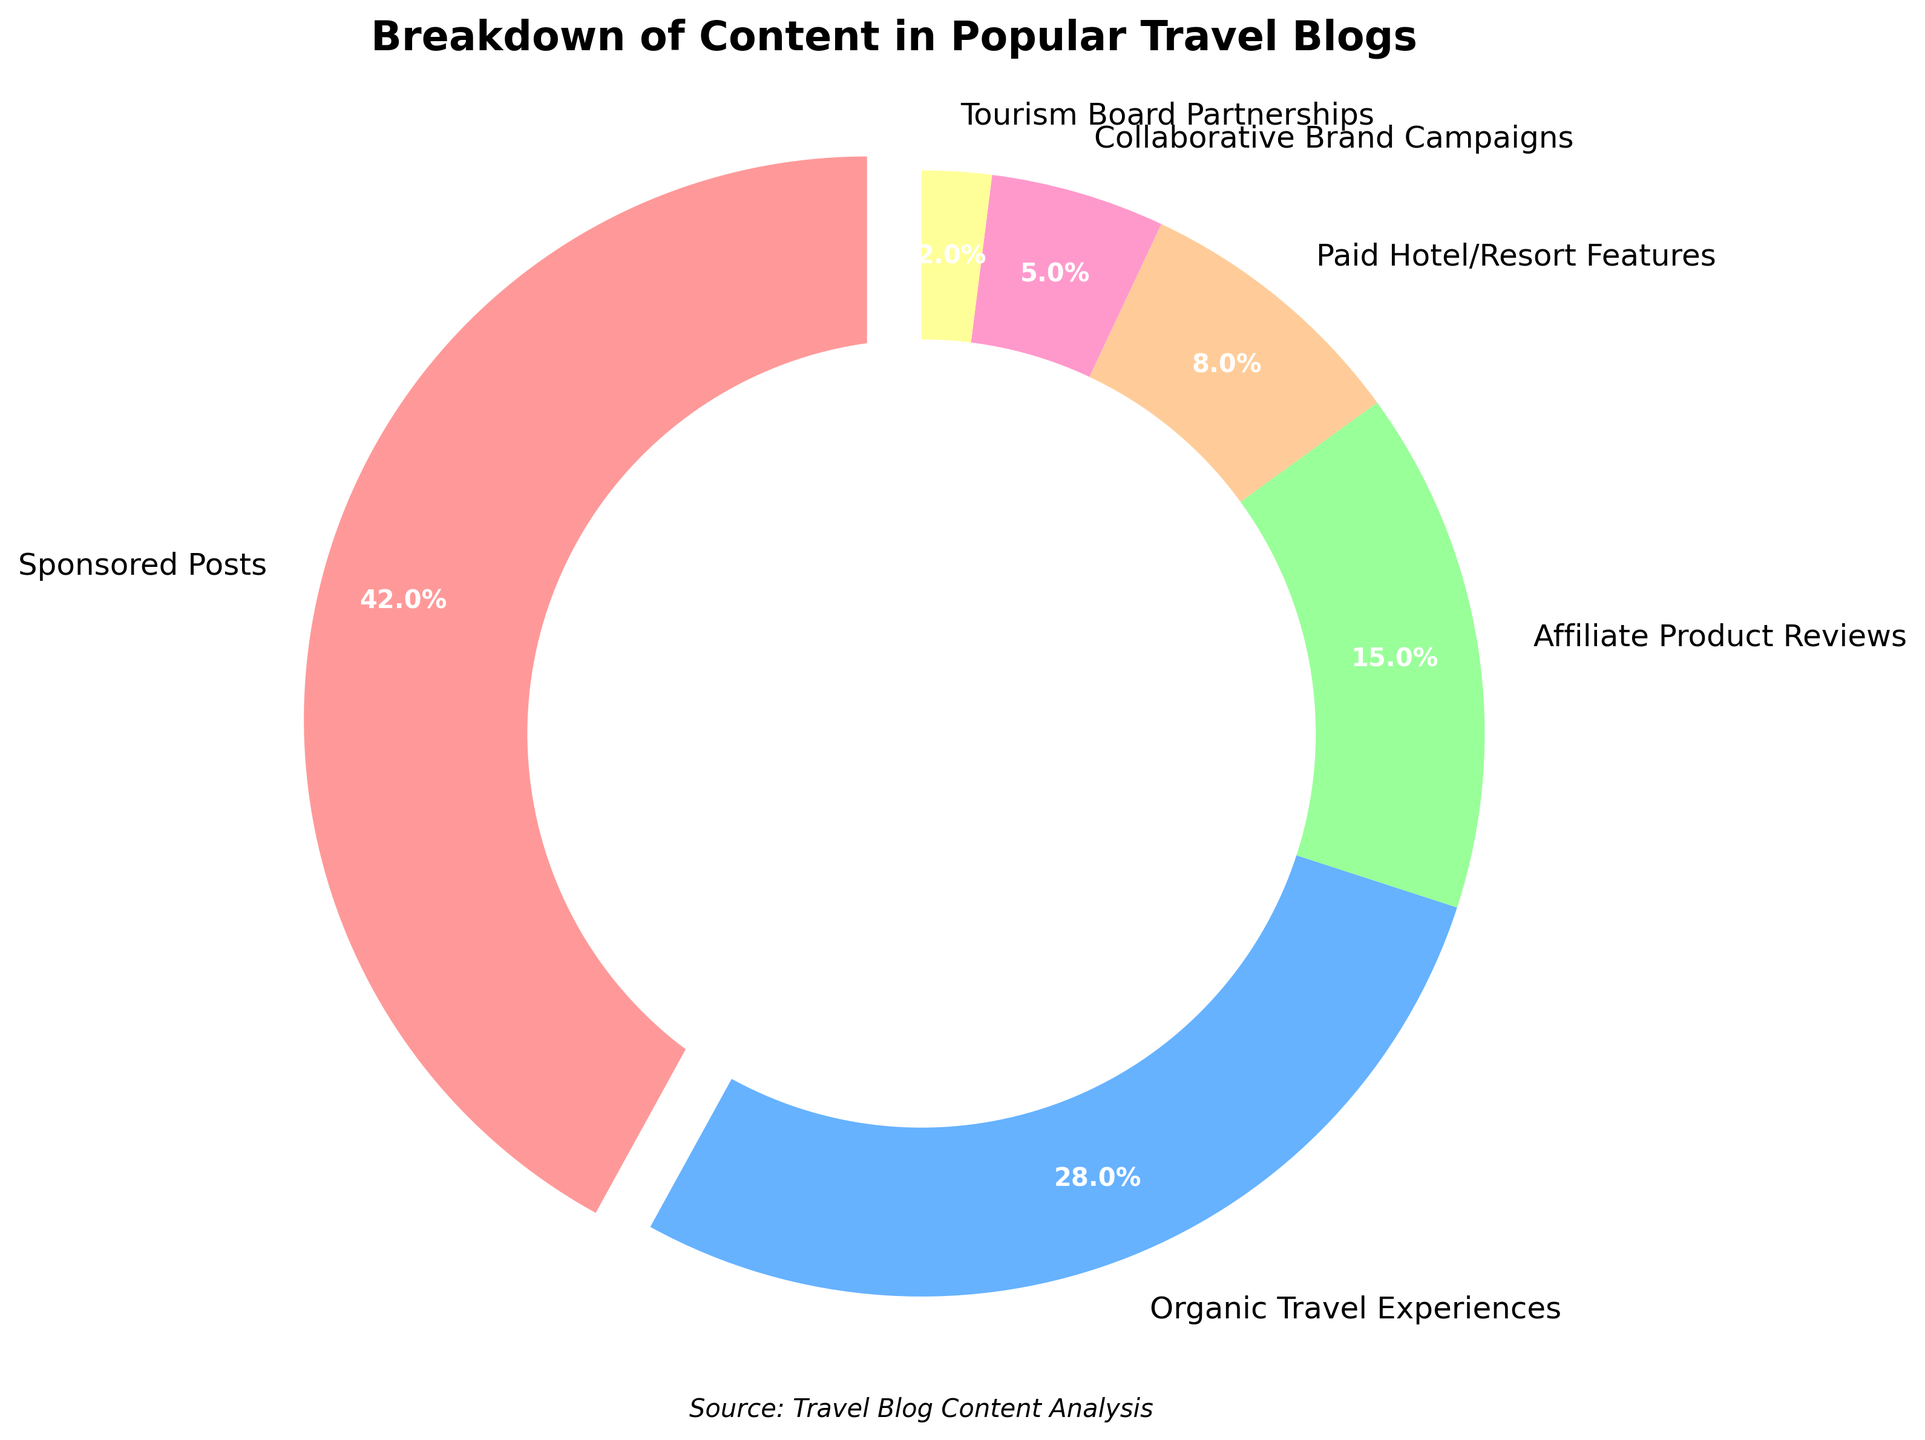What percentage of content in popular travel blogs is sponsored? According to the pie chart, "Sponsored Posts" account for a specific percentage of the total content. Inspect the label for "Sponsored Posts" to find this value.
Answer: 42% Which type of content has the smallest percentage in the pie chart? The pie chart shows several content types with their corresponding percentages. The label with the smallest value represents the type of content with the smallest percentage.
Answer: Tourism Board Partnerships What is the combined percentage of Affiliate Product Reviews and Paid Hotel/Resort Features? Find the individual percentages for "Affiliate Product Reviews" and "Paid Hotel/Resort Features." Add these two values together to get the combined percentage.
Answer: Affiliate Product Reviews (15%) + Paid Hotel/Resort Features (8%) = 23% Which has a higher percentage: Organic Travel Experiences or Collaborative Brand Campaigns? Compare the percentages given for "Organic Travel Experiences" and "Collaborative Brand Campaigns." Determine which one is higher.
Answer: Organic Travel Experiences How much larger is the percentage of Sponsored Posts compared to Organic Travel Experiences? Subtract the percentage of Organic Travel Experiences from the percentage of Sponsored Posts to find the difference.
Answer: 42% - 28% = 14% Which content type is represented by the red color? Identify the slice in the pie chart that is colored red. Check the corresponding label to determine the content type.
Answer: Sponsored Posts What percentage of content is not sponsored, if sponsored content includes Sponsored Posts, Paid Hotel/Resort Features, and Tourism Board Partnerships? Add the percentages of "Sponsored Posts," "Paid Hotel/Resort Features," and "Tourism Board Partnerships" to get the total sponsored content. Subtract this from 100% to find the remaining unsponsored content.
Answer: Sponsored Posts (42%) + Paid Hotel/Resort Features (8%) + Tourism Board Partnerships (2%) = 52%; 100% - 52% = 48% Is the percentage of Collaborative Brand Campaigns greater than or equal to Tourism Board Partnerships combined with Organic Travel Experiences? Add the percentages of "Tourism Board Partnerships" and "Organic Travel Experiences." Compare this sum with the percentage of "Collaborative Brand Campaigns."
Answer: Tourism Board Partnerships (2%) + Organic Travel Experiences (28%) = 30%; Collaborative Brand Campaigns = 5%; 5% is not greater than or equal to 30% What is the median percentage value among all the content types? Arrange the percentages in ascending order: 2%, 5%, 8%, 15%, 28%, 42%. With an even number of values, the median is the average of the two middle figures in this list.
Answer: (8% + 15%) / 2 = 11.5% 